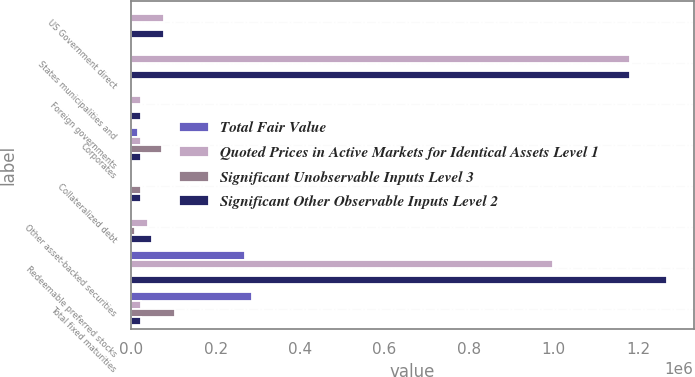Convert chart to OTSL. <chart><loc_0><loc_0><loc_500><loc_500><stacked_bar_chart><ecel><fcel>US Government direct<fcel>States municipalities and<fcel>Foreign governments<fcel>Corporates<fcel>Collateralized debt<fcel>Other asset-backed securities<fcel>Redeemable preferred stocks<fcel>Total fixed maturities<nl><fcel>Total Fair Value<fcel>0<fcel>0<fcel>0<fcel>15347<fcel>0<fcel>0<fcel>270189<fcel>285536<nl><fcel>Quoted Prices in Active Markets for Identical Assets Level 1<fcel>78674<fcel>1.18113e+06<fcel>23031<fcel>22743.5<fcel>0<fcel>40696<fcel>997955<fcel>22743.5<nl><fcel>Significant Unobservable Inputs Level 3<fcel>0<fcel>0<fcel>0<fcel>73673<fcel>22456<fcel>8042<fcel>0<fcel>104171<nl><fcel>Significant Other Observable Inputs Level 2<fcel>78674<fcel>1.18113e+06<fcel>23031<fcel>22743.5<fcel>22456<fcel>48738<fcel>1.26814e+06<fcel>22743.5<nl></chart> 